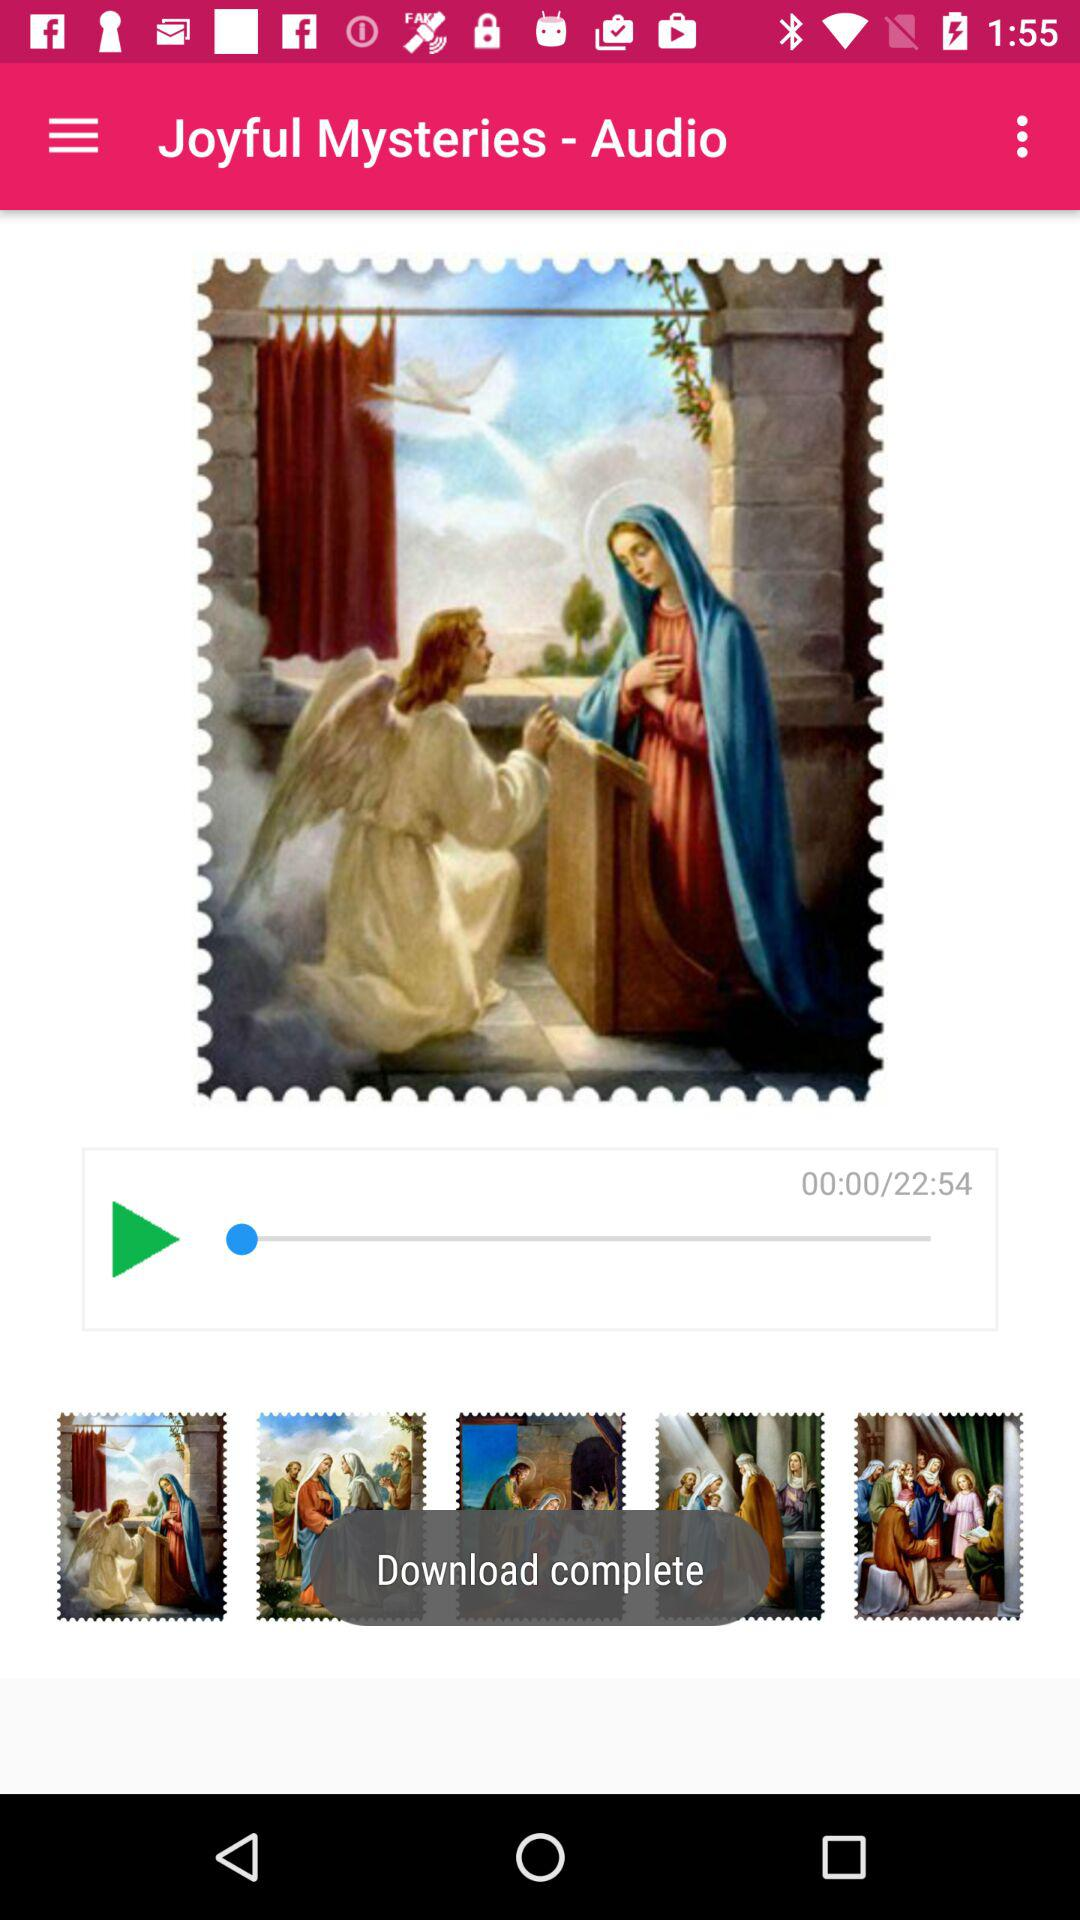What's the duration of the track? The duration of the track is 22 minutes 54 seconds. 